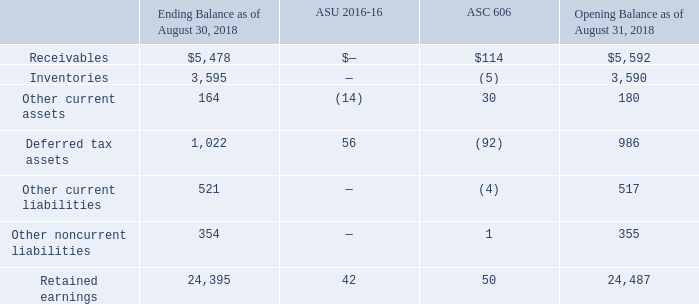Recently Adopted Accounting Standards
In October 2016, the Financial Accounting Standards Board ("FASB") issued Accounting Standards Update ("ASU") 2016-16 – Intra-Entity Transfers Other Than Inventory ("ASU 2016-16"), which requires an entity to recognize the income tax consequences of an intra-entity transfer of an asset other than inventory when the transfer occurs. We adopted this ASU in the first quarter of 2019 under the modified retrospective method and, in connection therewith, made certain adjustments as noted in the table below.
In January 2016, the FASB issued ASU 2016-01 – Recognition and Measurement of Financial Assets and Financial Liabilities, which provides guidance for the recognition, measurement, presentation, and disclosure of financial assets and liabilities. We adopted this ASU in the first quarter of 2019 under the modified retrospective method, with prospective adoption for amendments related to equity securities without readily determinable fair values. The adoption of this ASU did not have a material impact on our financial statements.
In May 2014, the FASB issued ASU 2014-09 – Revenue from Contracts with Customers (as amended, "ASC 606"), which supersedes nearly all existing revenue recognition guidance under generally accepted accounting principles in the United States. The core principal of ASC 606 is that an entity should recognize revenue when it transfers control of promised goods or services to customers in an amount that reflects the consideration to which the entity expects to be entitled in exchange for those goods or services. ASC 606 also requires additional disclosure about the nature, amount, timing, and uncertainty of revenue and cash flows arising from customer contracts, including significant judgments and changes in judgments, and assets recognized from costs incurred to obtain or fulfill a contract. We adopted ASC 606 in the first quarter of 2019 under the modified retrospective method and, in connection therewith, made certain adjustments as noted in the table below. We applied ASC 606 to contracts with customers that had not yet been completed as of the adoption date.
The following table summarizes the effects of adopting ASU 2016-16 and ASC 606:
As a result of the adoption of ASC 606, the opening balances as of August 31, 2018 for receivables, other current assets, and other current liabilities increased due to the reclassification of allowances for rebates, pricing adjustments, and returns to conform to the new presentation requirements. In addition, the margin from previously deferred sales to distributors was reclassified from other current liabilities to retained earnings. The tax effects of the adoption of ASC 606 were recorded primarily as a reduction of net deferred tax assets, substantially as a result of recognizing income for accounting purposes earlier under ASC 606 than for tax purposes in various jurisdictions.
What does Accounting Standards Update ("ASU") 2016-16 – Intra-Entity Transfers Other Than Inventory ("ASU 2016-16") specify? Requires an entity to recognize the income tax consequences of an intra-entity transfer of an asset other than inventory when the transfer occurs. What is the opening balance for retained earnings as of August 31, 2018? 24,487. What were the effects of adopting ASU 2016-16 and ASC 606 for other current assets respectively? (14), 30. What is the total opening balance for receivables and inventories as of August 31, 2018? 5,592+3,590 
Answer: 9182. What is the ratio of ending balance as of August 30, 2018, for other current liabilities to other noncurrent liabilities? 521/354 
Answer: 1.47. What is the percentage change of opening balance as of August 31, 2018, from ending balance in August 30, 2018, for receivables due to the adoption of ASC 606?
Answer scale should be: percent. ($5,592-$5,478)/$5,478 
Answer: 2.08. 